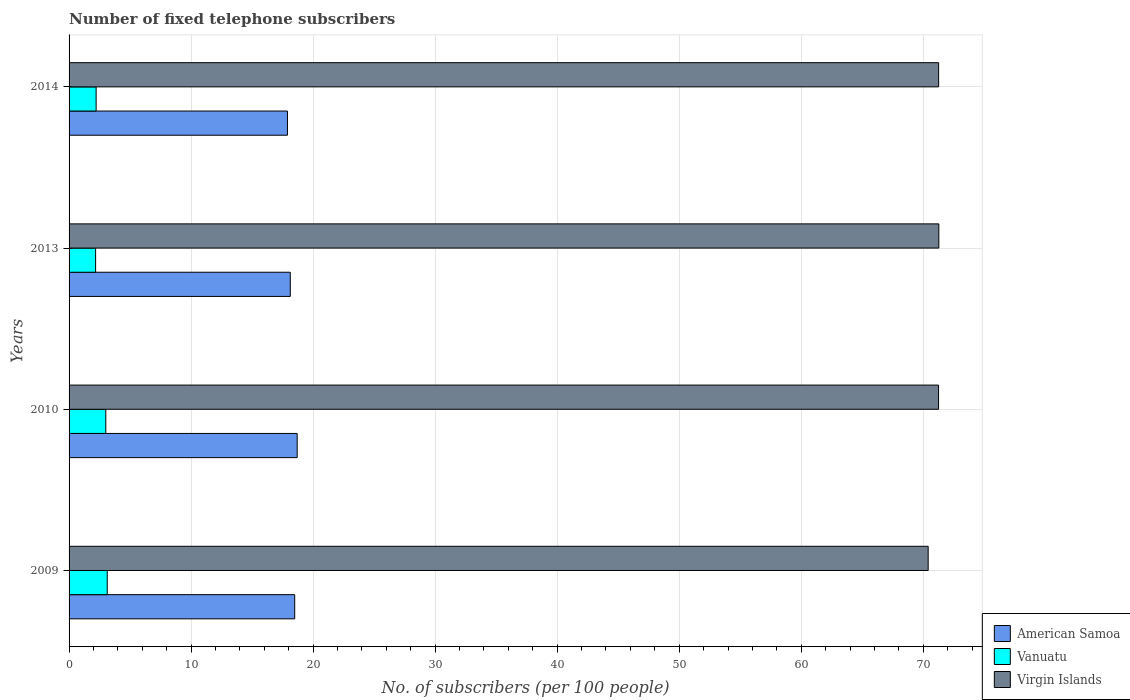How many groups of bars are there?
Your response must be concise. 4. How many bars are there on the 4th tick from the top?
Ensure brevity in your answer.  3. What is the label of the 1st group of bars from the top?
Make the answer very short. 2014. In how many cases, is the number of bars for a given year not equal to the number of legend labels?
Keep it short and to the point. 0. What is the number of fixed telephone subscribers in Vanuatu in 2010?
Your answer should be compact. 3.01. Across all years, what is the maximum number of fixed telephone subscribers in Virgin Islands?
Your answer should be compact. 71.28. Across all years, what is the minimum number of fixed telephone subscribers in Virgin Islands?
Provide a short and direct response. 70.4. What is the total number of fixed telephone subscribers in Vanuatu in the graph?
Give a very brief answer. 10.53. What is the difference between the number of fixed telephone subscribers in Vanuatu in 2013 and that in 2014?
Your answer should be compact. -0.04. What is the difference between the number of fixed telephone subscribers in American Samoa in 2014 and the number of fixed telephone subscribers in Vanuatu in 2013?
Provide a short and direct response. 15.72. What is the average number of fixed telephone subscribers in American Samoa per year?
Provide a succinct answer. 18.3. In the year 2013, what is the difference between the number of fixed telephone subscribers in American Samoa and number of fixed telephone subscribers in Virgin Islands?
Your answer should be compact. -53.15. What is the ratio of the number of fixed telephone subscribers in Virgin Islands in 2010 to that in 2014?
Your answer should be compact. 1. Is the number of fixed telephone subscribers in Virgin Islands in 2009 less than that in 2014?
Give a very brief answer. Yes. What is the difference between the highest and the second highest number of fixed telephone subscribers in American Samoa?
Your answer should be very brief. 0.2. What is the difference between the highest and the lowest number of fixed telephone subscribers in Virgin Islands?
Your answer should be compact. 0.87. What does the 1st bar from the top in 2010 represents?
Your answer should be compact. Virgin Islands. What does the 2nd bar from the bottom in 2013 represents?
Make the answer very short. Vanuatu. Is it the case that in every year, the sum of the number of fixed telephone subscribers in Virgin Islands and number of fixed telephone subscribers in Vanuatu is greater than the number of fixed telephone subscribers in American Samoa?
Give a very brief answer. Yes. How many bars are there?
Make the answer very short. 12. Are all the bars in the graph horizontal?
Give a very brief answer. Yes. How many years are there in the graph?
Provide a short and direct response. 4. Does the graph contain any zero values?
Keep it short and to the point. No. Where does the legend appear in the graph?
Ensure brevity in your answer.  Bottom right. What is the title of the graph?
Offer a very short reply. Number of fixed telephone subscribers. Does "Caribbean small states" appear as one of the legend labels in the graph?
Keep it short and to the point. No. What is the label or title of the X-axis?
Your response must be concise. No. of subscribers (per 100 people). What is the No. of subscribers (per 100 people) in American Samoa in 2009?
Your answer should be compact. 18.49. What is the No. of subscribers (per 100 people) in Vanuatu in 2009?
Your answer should be very brief. 3.13. What is the No. of subscribers (per 100 people) of Virgin Islands in 2009?
Provide a succinct answer. 70.4. What is the No. of subscribers (per 100 people) in American Samoa in 2010?
Your answer should be very brief. 18.69. What is the No. of subscribers (per 100 people) in Vanuatu in 2010?
Offer a very short reply. 3.01. What is the No. of subscribers (per 100 people) of Virgin Islands in 2010?
Your response must be concise. 71.25. What is the No. of subscribers (per 100 people) in American Samoa in 2013?
Provide a succinct answer. 18.13. What is the No. of subscribers (per 100 people) of Vanuatu in 2013?
Give a very brief answer. 2.17. What is the No. of subscribers (per 100 people) of Virgin Islands in 2013?
Your answer should be compact. 71.28. What is the No. of subscribers (per 100 people) of American Samoa in 2014?
Ensure brevity in your answer.  17.9. What is the No. of subscribers (per 100 people) in Vanuatu in 2014?
Your answer should be very brief. 2.22. What is the No. of subscribers (per 100 people) of Virgin Islands in 2014?
Your answer should be compact. 71.26. Across all years, what is the maximum No. of subscribers (per 100 people) of American Samoa?
Your answer should be very brief. 18.69. Across all years, what is the maximum No. of subscribers (per 100 people) in Vanuatu?
Provide a short and direct response. 3.13. Across all years, what is the maximum No. of subscribers (per 100 people) of Virgin Islands?
Your response must be concise. 71.28. Across all years, what is the minimum No. of subscribers (per 100 people) in American Samoa?
Your answer should be very brief. 17.9. Across all years, what is the minimum No. of subscribers (per 100 people) in Vanuatu?
Provide a short and direct response. 2.17. Across all years, what is the minimum No. of subscribers (per 100 people) of Virgin Islands?
Provide a short and direct response. 70.4. What is the total No. of subscribers (per 100 people) of American Samoa in the graph?
Offer a very short reply. 73.21. What is the total No. of subscribers (per 100 people) in Vanuatu in the graph?
Provide a short and direct response. 10.53. What is the total No. of subscribers (per 100 people) of Virgin Islands in the graph?
Make the answer very short. 284.19. What is the difference between the No. of subscribers (per 100 people) in American Samoa in 2009 and that in 2010?
Provide a succinct answer. -0.2. What is the difference between the No. of subscribers (per 100 people) of Vanuatu in 2009 and that in 2010?
Offer a terse response. 0.12. What is the difference between the No. of subscribers (per 100 people) in Virgin Islands in 2009 and that in 2010?
Ensure brevity in your answer.  -0.85. What is the difference between the No. of subscribers (per 100 people) in American Samoa in 2009 and that in 2013?
Ensure brevity in your answer.  0.36. What is the difference between the No. of subscribers (per 100 people) in Vanuatu in 2009 and that in 2013?
Provide a succinct answer. 0.95. What is the difference between the No. of subscribers (per 100 people) of Virgin Islands in 2009 and that in 2013?
Give a very brief answer. -0.87. What is the difference between the No. of subscribers (per 100 people) of American Samoa in 2009 and that in 2014?
Your response must be concise. 0.59. What is the difference between the No. of subscribers (per 100 people) in Vanuatu in 2009 and that in 2014?
Give a very brief answer. 0.91. What is the difference between the No. of subscribers (per 100 people) in Virgin Islands in 2009 and that in 2014?
Provide a short and direct response. -0.86. What is the difference between the No. of subscribers (per 100 people) in American Samoa in 2010 and that in 2013?
Provide a succinct answer. 0.57. What is the difference between the No. of subscribers (per 100 people) in Vanuatu in 2010 and that in 2013?
Your answer should be compact. 0.83. What is the difference between the No. of subscribers (per 100 people) of Virgin Islands in 2010 and that in 2013?
Keep it short and to the point. -0.02. What is the difference between the No. of subscribers (per 100 people) in American Samoa in 2010 and that in 2014?
Keep it short and to the point. 0.8. What is the difference between the No. of subscribers (per 100 people) in Vanuatu in 2010 and that in 2014?
Provide a short and direct response. 0.79. What is the difference between the No. of subscribers (per 100 people) in Virgin Islands in 2010 and that in 2014?
Provide a succinct answer. -0.01. What is the difference between the No. of subscribers (per 100 people) of American Samoa in 2013 and that in 2014?
Make the answer very short. 0.23. What is the difference between the No. of subscribers (per 100 people) in Vanuatu in 2013 and that in 2014?
Make the answer very short. -0.04. What is the difference between the No. of subscribers (per 100 people) of Virgin Islands in 2013 and that in 2014?
Your answer should be compact. 0.02. What is the difference between the No. of subscribers (per 100 people) in American Samoa in 2009 and the No. of subscribers (per 100 people) in Vanuatu in 2010?
Provide a short and direct response. 15.48. What is the difference between the No. of subscribers (per 100 people) of American Samoa in 2009 and the No. of subscribers (per 100 people) of Virgin Islands in 2010?
Keep it short and to the point. -52.76. What is the difference between the No. of subscribers (per 100 people) in Vanuatu in 2009 and the No. of subscribers (per 100 people) in Virgin Islands in 2010?
Ensure brevity in your answer.  -68.13. What is the difference between the No. of subscribers (per 100 people) in American Samoa in 2009 and the No. of subscribers (per 100 people) in Vanuatu in 2013?
Your response must be concise. 16.32. What is the difference between the No. of subscribers (per 100 people) of American Samoa in 2009 and the No. of subscribers (per 100 people) of Virgin Islands in 2013?
Offer a terse response. -52.79. What is the difference between the No. of subscribers (per 100 people) in Vanuatu in 2009 and the No. of subscribers (per 100 people) in Virgin Islands in 2013?
Offer a terse response. -68.15. What is the difference between the No. of subscribers (per 100 people) in American Samoa in 2009 and the No. of subscribers (per 100 people) in Vanuatu in 2014?
Offer a very short reply. 16.27. What is the difference between the No. of subscribers (per 100 people) of American Samoa in 2009 and the No. of subscribers (per 100 people) of Virgin Islands in 2014?
Provide a succinct answer. -52.77. What is the difference between the No. of subscribers (per 100 people) in Vanuatu in 2009 and the No. of subscribers (per 100 people) in Virgin Islands in 2014?
Your answer should be very brief. -68.13. What is the difference between the No. of subscribers (per 100 people) in American Samoa in 2010 and the No. of subscribers (per 100 people) in Vanuatu in 2013?
Offer a very short reply. 16.52. What is the difference between the No. of subscribers (per 100 people) of American Samoa in 2010 and the No. of subscribers (per 100 people) of Virgin Islands in 2013?
Keep it short and to the point. -52.58. What is the difference between the No. of subscribers (per 100 people) in Vanuatu in 2010 and the No. of subscribers (per 100 people) in Virgin Islands in 2013?
Keep it short and to the point. -68.27. What is the difference between the No. of subscribers (per 100 people) in American Samoa in 2010 and the No. of subscribers (per 100 people) in Vanuatu in 2014?
Your answer should be compact. 16.48. What is the difference between the No. of subscribers (per 100 people) in American Samoa in 2010 and the No. of subscribers (per 100 people) in Virgin Islands in 2014?
Offer a very short reply. -52.57. What is the difference between the No. of subscribers (per 100 people) in Vanuatu in 2010 and the No. of subscribers (per 100 people) in Virgin Islands in 2014?
Offer a terse response. -68.25. What is the difference between the No. of subscribers (per 100 people) in American Samoa in 2013 and the No. of subscribers (per 100 people) in Vanuatu in 2014?
Offer a very short reply. 15.91. What is the difference between the No. of subscribers (per 100 people) of American Samoa in 2013 and the No. of subscribers (per 100 people) of Virgin Islands in 2014?
Offer a very short reply. -53.13. What is the difference between the No. of subscribers (per 100 people) of Vanuatu in 2013 and the No. of subscribers (per 100 people) of Virgin Islands in 2014?
Offer a very short reply. -69.09. What is the average No. of subscribers (per 100 people) of American Samoa per year?
Keep it short and to the point. 18.3. What is the average No. of subscribers (per 100 people) in Vanuatu per year?
Keep it short and to the point. 2.63. What is the average No. of subscribers (per 100 people) of Virgin Islands per year?
Offer a very short reply. 71.05. In the year 2009, what is the difference between the No. of subscribers (per 100 people) of American Samoa and No. of subscribers (per 100 people) of Vanuatu?
Your answer should be very brief. 15.36. In the year 2009, what is the difference between the No. of subscribers (per 100 people) of American Samoa and No. of subscribers (per 100 people) of Virgin Islands?
Keep it short and to the point. -51.91. In the year 2009, what is the difference between the No. of subscribers (per 100 people) of Vanuatu and No. of subscribers (per 100 people) of Virgin Islands?
Offer a terse response. -67.28. In the year 2010, what is the difference between the No. of subscribers (per 100 people) in American Samoa and No. of subscribers (per 100 people) in Vanuatu?
Keep it short and to the point. 15.68. In the year 2010, what is the difference between the No. of subscribers (per 100 people) in American Samoa and No. of subscribers (per 100 people) in Virgin Islands?
Keep it short and to the point. -52.56. In the year 2010, what is the difference between the No. of subscribers (per 100 people) in Vanuatu and No. of subscribers (per 100 people) in Virgin Islands?
Offer a terse response. -68.24. In the year 2013, what is the difference between the No. of subscribers (per 100 people) of American Samoa and No. of subscribers (per 100 people) of Vanuatu?
Offer a terse response. 15.95. In the year 2013, what is the difference between the No. of subscribers (per 100 people) of American Samoa and No. of subscribers (per 100 people) of Virgin Islands?
Provide a succinct answer. -53.15. In the year 2013, what is the difference between the No. of subscribers (per 100 people) in Vanuatu and No. of subscribers (per 100 people) in Virgin Islands?
Provide a succinct answer. -69.1. In the year 2014, what is the difference between the No. of subscribers (per 100 people) in American Samoa and No. of subscribers (per 100 people) in Vanuatu?
Your response must be concise. 15.68. In the year 2014, what is the difference between the No. of subscribers (per 100 people) of American Samoa and No. of subscribers (per 100 people) of Virgin Islands?
Offer a very short reply. -53.36. In the year 2014, what is the difference between the No. of subscribers (per 100 people) of Vanuatu and No. of subscribers (per 100 people) of Virgin Islands?
Make the answer very short. -69.04. What is the ratio of the No. of subscribers (per 100 people) in Vanuatu in 2009 to that in 2010?
Ensure brevity in your answer.  1.04. What is the ratio of the No. of subscribers (per 100 people) in Virgin Islands in 2009 to that in 2010?
Your response must be concise. 0.99. What is the ratio of the No. of subscribers (per 100 people) of American Samoa in 2009 to that in 2013?
Your response must be concise. 1.02. What is the ratio of the No. of subscribers (per 100 people) in Vanuatu in 2009 to that in 2013?
Offer a very short reply. 1.44. What is the ratio of the No. of subscribers (per 100 people) in Virgin Islands in 2009 to that in 2013?
Provide a succinct answer. 0.99. What is the ratio of the No. of subscribers (per 100 people) in American Samoa in 2009 to that in 2014?
Your answer should be compact. 1.03. What is the ratio of the No. of subscribers (per 100 people) of Vanuatu in 2009 to that in 2014?
Your answer should be very brief. 1.41. What is the ratio of the No. of subscribers (per 100 people) in American Samoa in 2010 to that in 2013?
Keep it short and to the point. 1.03. What is the ratio of the No. of subscribers (per 100 people) of Vanuatu in 2010 to that in 2013?
Your answer should be compact. 1.38. What is the ratio of the No. of subscribers (per 100 people) of American Samoa in 2010 to that in 2014?
Provide a short and direct response. 1.04. What is the ratio of the No. of subscribers (per 100 people) of Vanuatu in 2010 to that in 2014?
Make the answer very short. 1.36. What is the ratio of the No. of subscribers (per 100 people) of American Samoa in 2013 to that in 2014?
Provide a succinct answer. 1.01. What is the ratio of the No. of subscribers (per 100 people) of Vanuatu in 2013 to that in 2014?
Give a very brief answer. 0.98. What is the ratio of the No. of subscribers (per 100 people) of Virgin Islands in 2013 to that in 2014?
Your response must be concise. 1. What is the difference between the highest and the second highest No. of subscribers (per 100 people) of American Samoa?
Your answer should be compact. 0.2. What is the difference between the highest and the second highest No. of subscribers (per 100 people) of Vanuatu?
Your answer should be compact. 0.12. What is the difference between the highest and the second highest No. of subscribers (per 100 people) in Virgin Islands?
Offer a very short reply. 0.02. What is the difference between the highest and the lowest No. of subscribers (per 100 people) of American Samoa?
Your answer should be compact. 0.8. What is the difference between the highest and the lowest No. of subscribers (per 100 people) of Vanuatu?
Your answer should be very brief. 0.95. What is the difference between the highest and the lowest No. of subscribers (per 100 people) of Virgin Islands?
Offer a terse response. 0.87. 